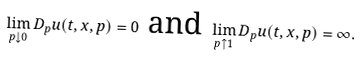<formula> <loc_0><loc_0><loc_500><loc_500>\lim _ { p \downarrow 0 } D _ { p } u ( t , x , p ) = 0 \ \text {and} \ \lim _ { p \uparrow 1 } D _ { p } u ( t , x , p ) = \infty .</formula> 